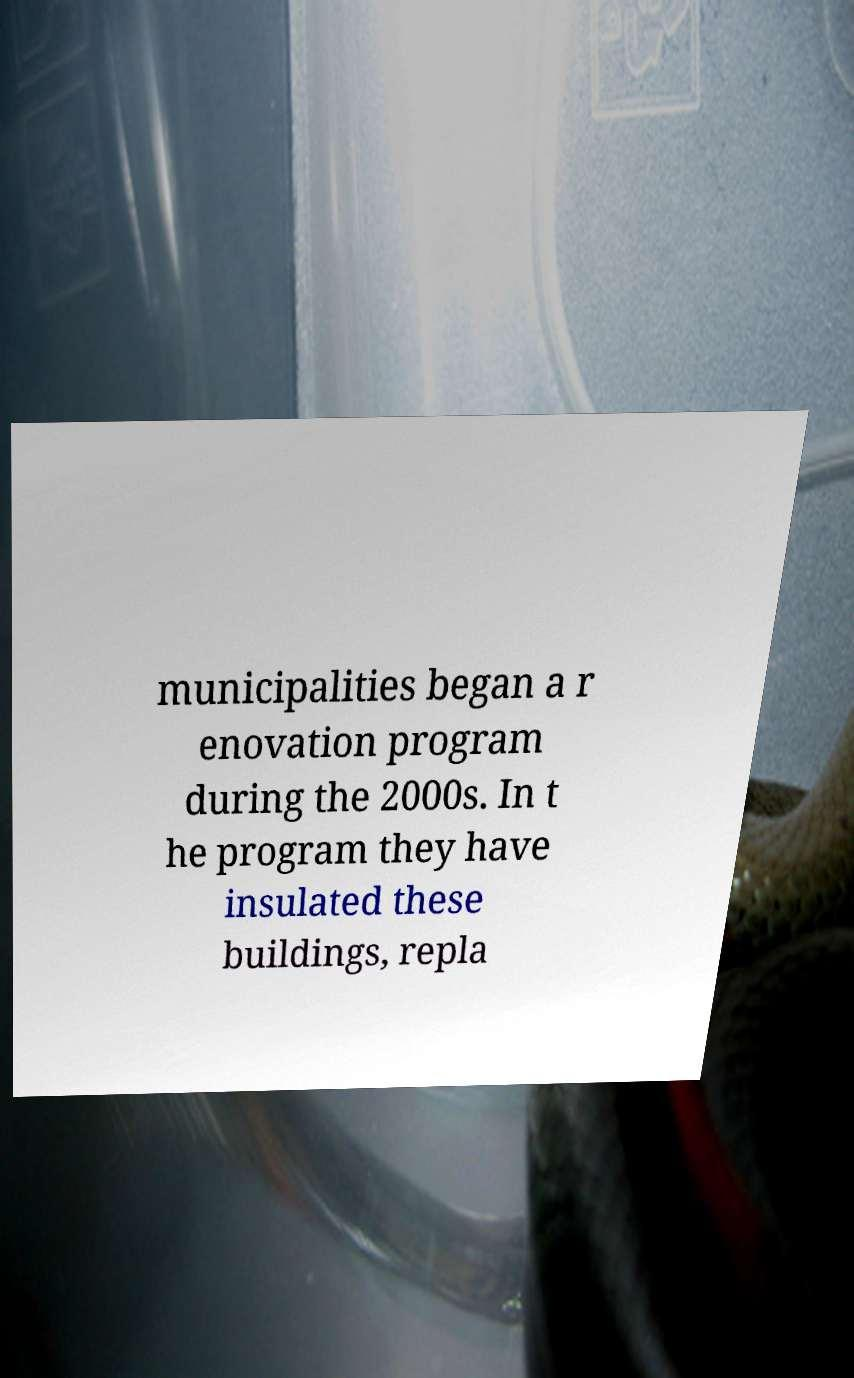Can you accurately transcribe the text from the provided image for me? municipalities began a r enovation program during the 2000s. In t he program they have insulated these buildings, repla 